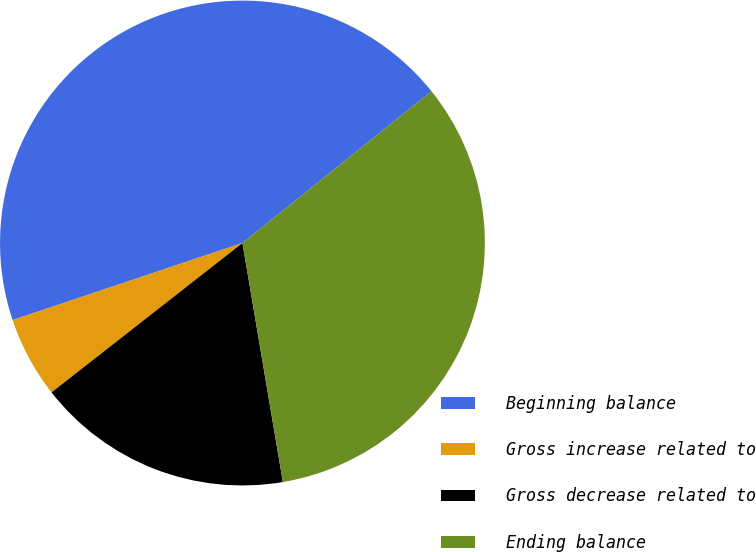Convert chart to OTSL. <chart><loc_0><loc_0><loc_500><loc_500><pie_chart><fcel>Beginning balance<fcel>Gross increase related to<fcel>Gross decrease related to<fcel>Ending balance<nl><fcel>44.38%<fcel>5.42%<fcel>17.1%<fcel>33.1%<nl></chart> 